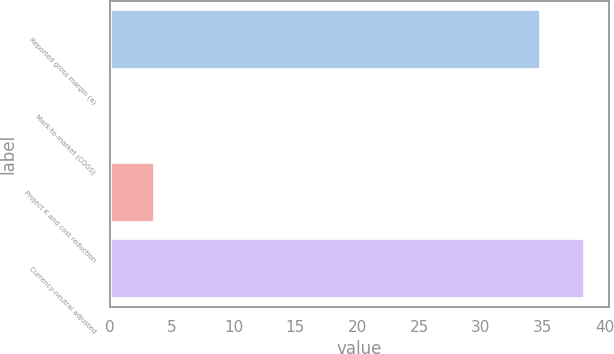Convert chart to OTSL. <chart><loc_0><loc_0><loc_500><loc_500><bar_chart><fcel>Reported gross margin (a)<fcel>Mark-to-market (COGS)<fcel>Project K and cost reduction<fcel>Currency-neutral adjusted<nl><fcel>34.9<fcel>0.1<fcel>3.64<fcel>38.44<nl></chart> 